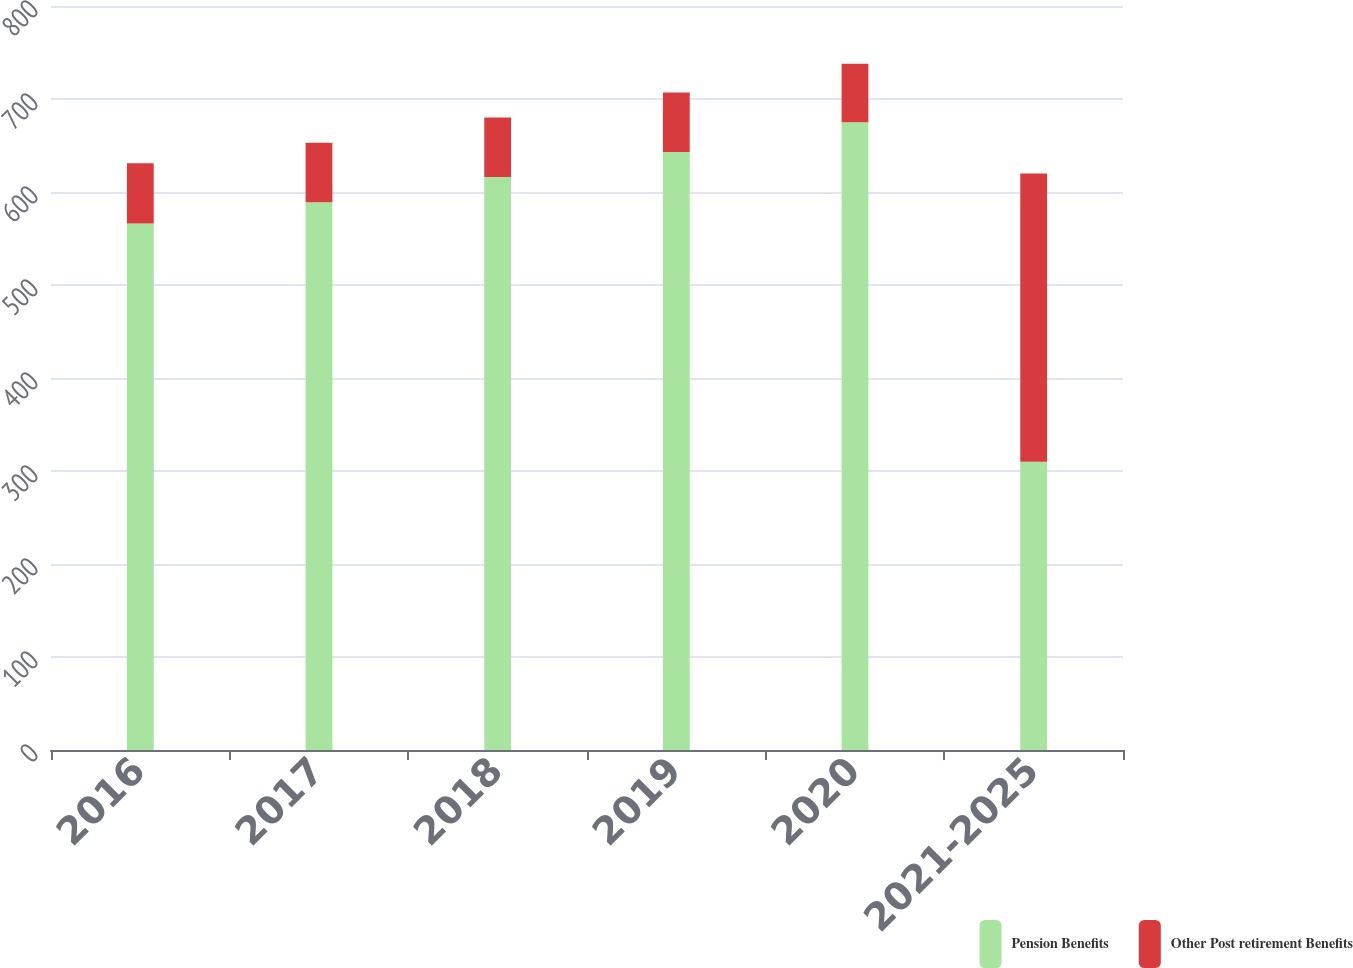Convert chart. <chart><loc_0><loc_0><loc_500><loc_500><stacked_bar_chart><ecel><fcel>2016<fcel>2017<fcel>2018<fcel>2019<fcel>2020<fcel>2021-2025<nl><fcel>Pension Benefits<fcel>566<fcel>589<fcel>616<fcel>643<fcel>675<fcel>310<nl><fcel>Other Post retirement Benefits<fcel>65<fcel>64<fcel>64<fcel>64<fcel>63<fcel>310<nl></chart> 